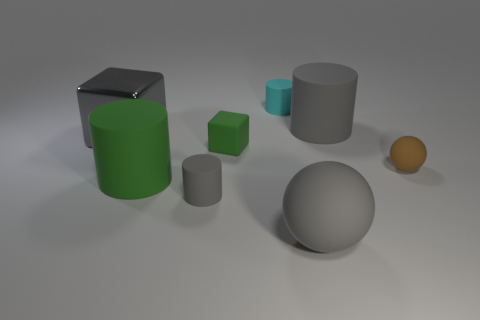Subtract all small cyan cylinders. How many cylinders are left? 3 Add 2 big purple rubber balls. How many objects exist? 10 Subtract all brown blocks. How many gray cylinders are left? 2 Subtract all green cylinders. How many cylinders are left? 3 Subtract all cubes. How many objects are left? 6 Subtract 3 cylinders. How many cylinders are left? 1 Add 6 tiny gray cylinders. How many tiny gray cylinders exist? 7 Subtract 0 yellow cylinders. How many objects are left? 8 Subtract all green blocks. Subtract all blue balls. How many blocks are left? 1 Subtract all large green shiny cylinders. Subtract all big gray metallic objects. How many objects are left? 7 